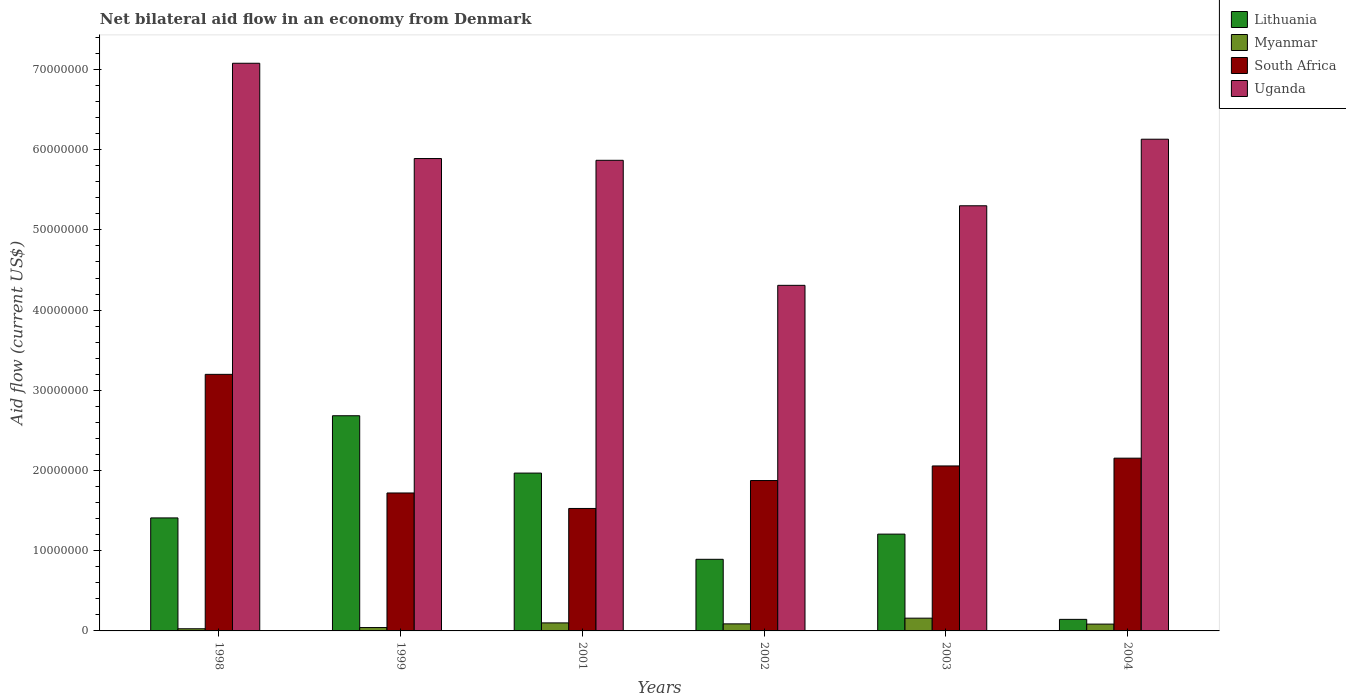How many different coloured bars are there?
Your response must be concise. 4. How many groups of bars are there?
Provide a succinct answer. 6. Are the number of bars per tick equal to the number of legend labels?
Offer a terse response. Yes. Are the number of bars on each tick of the X-axis equal?
Your answer should be very brief. Yes. How many bars are there on the 2nd tick from the left?
Offer a very short reply. 4. How many bars are there on the 1st tick from the right?
Offer a terse response. 4. What is the label of the 4th group of bars from the left?
Provide a succinct answer. 2002. In how many cases, is the number of bars for a given year not equal to the number of legend labels?
Make the answer very short. 0. What is the net bilateral aid flow in Myanmar in 1999?
Provide a succinct answer. 4.20e+05. Across all years, what is the maximum net bilateral aid flow in Myanmar?
Keep it short and to the point. 1.59e+06. Across all years, what is the minimum net bilateral aid flow in South Africa?
Your answer should be very brief. 1.53e+07. In which year was the net bilateral aid flow in Lithuania minimum?
Provide a short and direct response. 2004. What is the total net bilateral aid flow in Myanmar in the graph?
Your answer should be very brief. 5.01e+06. What is the difference between the net bilateral aid flow in Lithuania in 1998 and that in 2003?
Make the answer very short. 2.02e+06. What is the difference between the net bilateral aid flow in Lithuania in 1998 and the net bilateral aid flow in South Africa in 2001?
Provide a succinct answer. -1.18e+06. What is the average net bilateral aid flow in Lithuania per year?
Your response must be concise. 1.38e+07. In the year 2004, what is the difference between the net bilateral aid flow in South Africa and net bilateral aid flow in Lithuania?
Keep it short and to the point. 2.01e+07. What is the ratio of the net bilateral aid flow in South Africa in 2001 to that in 2003?
Make the answer very short. 0.74. Is the net bilateral aid flow in Lithuania in 2001 less than that in 2004?
Keep it short and to the point. No. What is the difference between the highest and the second highest net bilateral aid flow in South Africa?
Your response must be concise. 1.04e+07. What is the difference between the highest and the lowest net bilateral aid flow in Lithuania?
Keep it short and to the point. 2.54e+07. Is it the case that in every year, the sum of the net bilateral aid flow in South Africa and net bilateral aid flow in Uganda is greater than the sum of net bilateral aid flow in Myanmar and net bilateral aid flow in Lithuania?
Offer a terse response. Yes. What does the 1st bar from the left in 1998 represents?
Make the answer very short. Lithuania. What does the 1st bar from the right in 1999 represents?
Give a very brief answer. Uganda. Is it the case that in every year, the sum of the net bilateral aid flow in Uganda and net bilateral aid flow in Myanmar is greater than the net bilateral aid flow in South Africa?
Your response must be concise. Yes. Are all the bars in the graph horizontal?
Make the answer very short. No. How many years are there in the graph?
Keep it short and to the point. 6. What is the difference between two consecutive major ticks on the Y-axis?
Offer a very short reply. 1.00e+07. Are the values on the major ticks of Y-axis written in scientific E-notation?
Provide a succinct answer. No. Where does the legend appear in the graph?
Offer a terse response. Top right. How are the legend labels stacked?
Make the answer very short. Vertical. What is the title of the graph?
Your response must be concise. Net bilateral aid flow in an economy from Denmark. Does "Mongolia" appear as one of the legend labels in the graph?
Keep it short and to the point. No. What is the label or title of the X-axis?
Your answer should be compact. Years. What is the label or title of the Y-axis?
Provide a short and direct response. Aid flow (current US$). What is the Aid flow (current US$) in Lithuania in 1998?
Provide a succinct answer. 1.41e+07. What is the Aid flow (current US$) of Myanmar in 1998?
Offer a terse response. 2.70e+05. What is the Aid flow (current US$) of South Africa in 1998?
Give a very brief answer. 3.20e+07. What is the Aid flow (current US$) in Uganda in 1998?
Make the answer very short. 7.08e+07. What is the Aid flow (current US$) of Lithuania in 1999?
Ensure brevity in your answer.  2.68e+07. What is the Aid flow (current US$) in South Africa in 1999?
Make the answer very short. 1.72e+07. What is the Aid flow (current US$) of Uganda in 1999?
Ensure brevity in your answer.  5.89e+07. What is the Aid flow (current US$) in Lithuania in 2001?
Your answer should be compact. 1.97e+07. What is the Aid flow (current US$) of Myanmar in 2001?
Offer a terse response. 1.00e+06. What is the Aid flow (current US$) in South Africa in 2001?
Keep it short and to the point. 1.53e+07. What is the Aid flow (current US$) of Uganda in 2001?
Your answer should be very brief. 5.87e+07. What is the Aid flow (current US$) in Lithuania in 2002?
Offer a terse response. 8.93e+06. What is the Aid flow (current US$) in Myanmar in 2002?
Offer a terse response. 8.80e+05. What is the Aid flow (current US$) of South Africa in 2002?
Your answer should be compact. 1.88e+07. What is the Aid flow (current US$) of Uganda in 2002?
Keep it short and to the point. 4.31e+07. What is the Aid flow (current US$) of Lithuania in 2003?
Give a very brief answer. 1.21e+07. What is the Aid flow (current US$) of Myanmar in 2003?
Offer a terse response. 1.59e+06. What is the Aid flow (current US$) in South Africa in 2003?
Provide a short and direct response. 2.06e+07. What is the Aid flow (current US$) in Uganda in 2003?
Make the answer very short. 5.30e+07. What is the Aid flow (current US$) in Lithuania in 2004?
Offer a very short reply. 1.44e+06. What is the Aid flow (current US$) of Myanmar in 2004?
Your answer should be very brief. 8.50e+05. What is the Aid flow (current US$) in South Africa in 2004?
Keep it short and to the point. 2.15e+07. What is the Aid flow (current US$) in Uganda in 2004?
Provide a succinct answer. 6.13e+07. Across all years, what is the maximum Aid flow (current US$) of Lithuania?
Your response must be concise. 2.68e+07. Across all years, what is the maximum Aid flow (current US$) in Myanmar?
Offer a terse response. 1.59e+06. Across all years, what is the maximum Aid flow (current US$) in South Africa?
Keep it short and to the point. 3.20e+07. Across all years, what is the maximum Aid flow (current US$) in Uganda?
Provide a short and direct response. 7.08e+07. Across all years, what is the minimum Aid flow (current US$) of Lithuania?
Your answer should be compact. 1.44e+06. Across all years, what is the minimum Aid flow (current US$) of South Africa?
Your response must be concise. 1.53e+07. Across all years, what is the minimum Aid flow (current US$) in Uganda?
Offer a very short reply. 4.31e+07. What is the total Aid flow (current US$) of Lithuania in the graph?
Provide a succinct answer. 8.30e+07. What is the total Aid flow (current US$) of Myanmar in the graph?
Ensure brevity in your answer.  5.01e+06. What is the total Aid flow (current US$) in South Africa in the graph?
Your answer should be compact. 1.25e+08. What is the total Aid flow (current US$) in Uganda in the graph?
Offer a terse response. 3.46e+08. What is the difference between the Aid flow (current US$) of Lithuania in 1998 and that in 1999?
Make the answer very short. -1.27e+07. What is the difference between the Aid flow (current US$) of South Africa in 1998 and that in 1999?
Provide a succinct answer. 1.48e+07. What is the difference between the Aid flow (current US$) in Uganda in 1998 and that in 1999?
Offer a terse response. 1.19e+07. What is the difference between the Aid flow (current US$) in Lithuania in 1998 and that in 2001?
Offer a very short reply. -5.59e+06. What is the difference between the Aid flow (current US$) in Myanmar in 1998 and that in 2001?
Keep it short and to the point. -7.30e+05. What is the difference between the Aid flow (current US$) of South Africa in 1998 and that in 2001?
Offer a terse response. 1.67e+07. What is the difference between the Aid flow (current US$) in Uganda in 1998 and that in 2001?
Your response must be concise. 1.21e+07. What is the difference between the Aid flow (current US$) in Lithuania in 1998 and that in 2002?
Give a very brief answer. 5.16e+06. What is the difference between the Aid flow (current US$) of Myanmar in 1998 and that in 2002?
Make the answer very short. -6.10e+05. What is the difference between the Aid flow (current US$) in South Africa in 1998 and that in 2002?
Provide a succinct answer. 1.32e+07. What is the difference between the Aid flow (current US$) in Uganda in 1998 and that in 2002?
Provide a succinct answer. 2.77e+07. What is the difference between the Aid flow (current US$) of Lithuania in 1998 and that in 2003?
Provide a short and direct response. 2.02e+06. What is the difference between the Aid flow (current US$) of Myanmar in 1998 and that in 2003?
Your answer should be compact. -1.32e+06. What is the difference between the Aid flow (current US$) in South Africa in 1998 and that in 2003?
Provide a short and direct response. 1.14e+07. What is the difference between the Aid flow (current US$) in Uganda in 1998 and that in 2003?
Keep it short and to the point. 1.78e+07. What is the difference between the Aid flow (current US$) in Lithuania in 1998 and that in 2004?
Keep it short and to the point. 1.26e+07. What is the difference between the Aid flow (current US$) of Myanmar in 1998 and that in 2004?
Offer a terse response. -5.80e+05. What is the difference between the Aid flow (current US$) in South Africa in 1998 and that in 2004?
Offer a very short reply. 1.04e+07. What is the difference between the Aid flow (current US$) of Uganda in 1998 and that in 2004?
Make the answer very short. 9.47e+06. What is the difference between the Aid flow (current US$) of Lithuania in 1999 and that in 2001?
Provide a short and direct response. 7.15e+06. What is the difference between the Aid flow (current US$) of Myanmar in 1999 and that in 2001?
Provide a succinct answer. -5.80e+05. What is the difference between the Aid flow (current US$) in South Africa in 1999 and that in 2001?
Ensure brevity in your answer.  1.93e+06. What is the difference between the Aid flow (current US$) of Uganda in 1999 and that in 2001?
Make the answer very short. 2.20e+05. What is the difference between the Aid flow (current US$) in Lithuania in 1999 and that in 2002?
Ensure brevity in your answer.  1.79e+07. What is the difference between the Aid flow (current US$) of Myanmar in 1999 and that in 2002?
Offer a terse response. -4.60e+05. What is the difference between the Aid flow (current US$) in South Africa in 1999 and that in 2002?
Make the answer very short. -1.55e+06. What is the difference between the Aid flow (current US$) of Uganda in 1999 and that in 2002?
Give a very brief answer. 1.58e+07. What is the difference between the Aid flow (current US$) in Lithuania in 1999 and that in 2003?
Provide a succinct answer. 1.48e+07. What is the difference between the Aid flow (current US$) of Myanmar in 1999 and that in 2003?
Your answer should be compact. -1.17e+06. What is the difference between the Aid flow (current US$) in South Africa in 1999 and that in 2003?
Make the answer very short. -3.37e+06. What is the difference between the Aid flow (current US$) in Uganda in 1999 and that in 2003?
Offer a terse response. 5.89e+06. What is the difference between the Aid flow (current US$) in Lithuania in 1999 and that in 2004?
Provide a succinct answer. 2.54e+07. What is the difference between the Aid flow (current US$) of Myanmar in 1999 and that in 2004?
Your answer should be very brief. -4.30e+05. What is the difference between the Aid flow (current US$) of South Africa in 1999 and that in 2004?
Your response must be concise. -4.34e+06. What is the difference between the Aid flow (current US$) of Uganda in 1999 and that in 2004?
Provide a succinct answer. -2.41e+06. What is the difference between the Aid flow (current US$) of Lithuania in 2001 and that in 2002?
Keep it short and to the point. 1.08e+07. What is the difference between the Aid flow (current US$) of Myanmar in 2001 and that in 2002?
Your answer should be very brief. 1.20e+05. What is the difference between the Aid flow (current US$) in South Africa in 2001 and that in 2002?
Provide a short and direct response. -3.48e+06. What is the difference between the Aid flow (current US$) in Uganda in 2001 and that in 2002?
Provide a succinct answer. 1.56e+07. What is the difference between the Aid flow (current US$) of Lithuania in 2001 and that in 2003?
Offer a terse response. 7.61e+06. What is the difference between the Aid flow (current US$) in Myanmar in 2001 and that in 2003?
Offer a very short reply. -5.90e+05. What is the difference between the Aid flow (current US$) in South Africa in 2001 and that in 2003?
Provide a short and direct response. -5.30e+06. What is the difference between the Aid flow (current US$) of Uganda in 2001 and that in 2003?
Keep it short and to the point. 5.67e+06. What is the difference between the Aid flow (current US$) of Lithuania in 2001 and that in 2004?
Offer a very short reply. 1.82e+07. What is the difference between the Aid flow (current US$) of South Africa in 2001 and that in 2004?
Your answer should be compact. -6.27e+06. What is the difference between the Aid flow (current US$) in Uganda in 2001 and that in 2004?
Provide a succinct answer. -2.63e+06. What is the difference between the Aid flow (current US$) of Lithuania in 2002 and that in 2003?
Give a very brief answer. -3.14e+06. What is the difference between the Aid flow (current US$) in Myanmar in 2002 and that in 2003?
Provide a succinct answer. -7.10e+05. What is the difference between the Aid flow (current US$) of South Africa in 2002 and that in 2003?
Your response must be concise. -1.82e+06. What is the difference between the Aid flow (current US$) in Uganda in 2002 and that in 2003?
Offer a very short reply. -9.92e+06. What is the difference between the Aid flow (current US$) of Lithuania in 2002 and that in 2004?
Keep it short and to the point. 7.49e+06. What is the difference between the Aid flow (current US$) in Myanmar in 2002 and that in 2004?
Make the answer very short. 3.00e+04. What is the difference between the Aid flow (current US$) in South Africa in 2002 and that in 2004?
Your answer should be compact. -2.79e+06. What is the difference between the Aid flow (current US$) in Uganda in 2002 and that in 2004?
Your answer should be very brief. -1.82e+07. What is the difference between the Aid flow (current US$) of Lithuania in 2003 and that in 2004?
Give a very brief answer. 1.06e+07. What is the difference between the Aid flow (current US$) in Myanmar in 2003 and that in 2004?
Your answer should be compact. 7.40e+05. What is the difference between the Aid flow (current US$) of South Africa in 2003 and that in 2004?
Your response must be concise. -9.70e+05. What is the difference between the Aid flow (current US$) in Uganda in 2003 and that in 2004?
Provide a short and direct response. -8.30e+06. What is the difference between the Aid flow (current US$) in Lithuania in 1998 and the Aid flow (current US$) in Myanmar in 1999?
Keep it short and to the point. 1.37e+07. What is the difference between the Aid flow (current US$) in Lithuania in 1998 and the Aid flow (current US$) in South Africa in 1999?
Keep it short and to the point. -3.11e+06. What is the difference between the Aid flow (current US$) in Lithuania in 1998 and the Aid flow (current US$) in Uganda in 1999?
Offer a very short reply. -4.48e+07. What is the difference between the Aid flow (current US$) in Myanmar in 1998 and the Aid flow (current US$) in South Africa in 1999?
Offer a very short reply. -1.69e+07. What is the difference between the Aid flow (current US$) in Myanmar in 1998 and the Aid flow (current US$) in Uganda in 1999?
Offer a terse response. -5.86e+07. What is the difference between the Aid flow (current US$) in South Africa in 1998 and the Aid flow (current US$) in Uganda in 1999?
Your answer should be compact. -2.69e+07. What is the difference between the Aid flow (current US$) in Lithuania in 1998 and the Aid flow (current US$) in Myanmar in 2001?
Make the answer very short. 1.31e+07. What is the difference between the Aid flow (current US$) of Lithuania in 1998 and the Aid flow (current US$) of South Africa in 2001?
Give a very brief answer. -1.18e+06. What is the difference between the Aid flow (current US$) of Lithuania in 1998 and the Aid flow (current US$) of Uganda in 2001?
Make the answer very short. -4.46e+07. What is the difference between the Aid flow (current US$) of Myanmar in 1998 and the Aid flow (current US$) of South Africa in 2001?
Offer a very short reply. -1.50e+07. What is the difference between the Aid flow (current US$) in Myanmar in 1998 and the Aid flow (current US$) in Uganda in 2001?
Make the answer very short. -5.84e+07. What is the difference between the Aid flow (current US$) of South Africa in 1998 and the Aid flow (current US$) of Uganda in 2001?
Provide a short and direct response. -2.67e+07. What is the difference between the Aid flow (current US$) of Lithuania in 1998 and the Aid flow (current US$) of Myanmar in 2002?
Provide a succinct answer. 1.32e+07. What is the difference between the Aid flow (current US$) in Lithuania in 1998 and the Aid flow (current US$) in South Africa in 2002?
Your answer should be very brief. -4.66e+06. What is the difference between the Aid flow (current US$) of Lithuania in 1998 and the Aid flow (current US$) of Uganda in 2002?
Ensure brevity in your answer.  -2.90e+07. What is the difference between the Aid flow (current US$) of Myanmar in 1998 and the Aid flow (current US$) of South Africa in 2002?
Offer a terse response. -1.85e+07. What is the difference between the Aid flow (current US$) in Myanmar in 1998 and the Aid flow (current US$) in Uganda in 2002?
Make the answer very short. -4.28e+07. What is the difference between the Aid flow (current US$) in South Africa in 1998 and the Aid flow (current US$) in Uganda in 2002?
Make the answer very short. -1.11e+07. What is the difference between the Aid flow (current US$) of Lithuania in 1998 and the Aid flow (current US$) of Myanmar in 2003?
Give a very brief answer. 1.25e+07. What is the difference between the Aid flow (current US$) of Lithuania in 1998 and the Aid flow (current US$) of South Africa in 2003?
Give a very brief answer. -6.48e+06. What is the difference between the Aid flow (current US$) of Lithuania in 1998 and the Aid flow (current US$) of Uganda in 2003?
Provide a short and direct response. -3.89e+07. What is the difference between the Aid flow (current US$) in Myanmar in 1998 and the Aid flow (current US$) in South Africa in 2003?
Provide a succinct answer. -2.03e+07. What is the difference between the Aid flow (current US$) in Myanmar in 1998 and the Aid flow (current US$) in Uganda in 2003?
Offer a terse response. -5.27e+07. What is the difference between the Aid flow (current US$) in South Africa in 1998 and the Aid flow (current US$) in Uganda in 2003?
Your response must be concise. -2.10e+07. What is the difference between the Aid flow (current US$) of Lithuania in 1998 and the Aid flow (current US$) of Myanmar in 2004?
Keep it short and to the point. 1.32e+07. What is the difference between the Aid flow (current US$) in Lithuania in 1998 and the Aid flow (current US$) in South Africa in 2004?
Ensure brevity in your answer.  -7.45e+06. What is the difference between the Aid flow (current US$) in Lithuania in 1998 and the Aid flow (current US$) in Uganda in 2004?
Your answer should be very brief. -4.72e+07. What is the difference between the Aid flow (current US$) of Myanmar in 1998 and the Aid flow (current US$) of South Africa in 2004?
Offer a very short reply. -2.13e+07. What is the difference between the Aid flow (current US$) in Myanmar in 1998 and the Aid flow (current US$) in Uganda in 2004?
Make the answer very short. -6.10e+07. What is the difference between the Aid flow (current US$) in South Africa in 1998 and the Aid flow (current US$) in Uganda in 2004?
Give a very brief answer. -2.93e+07. What is the difference between the Aid flow (current US$) in Lithuania in 1999 and the Aid flow (current US$) in Myanmar in 2001?
Your response must be concise. 2.58e+07. What is the difference between the Aid flow (current US$) of Lithuania in 1999 and the Aid flow (current US$) of South Africa in 2001?
Give a very brief answer. 1.16e+07. What is the difference between the Aid flow (current US$) of Lithuania in 1999 and the Aid flow (current US$) of Uganda in 2001?
Offer a terse response. -3.18e+07. What is the difference between the Aid flow (current US$) in Myanmar in 1999 and the Aid flow (current US$) in South Africa in 2001?
Make the answer very short. -1.48e+07. What is the difference between the Aid flow (current US$) in Myanmar in 1999 and the Aid flow (current US$) in Uganda in 2001?
Your answer should be compact. -5.83e+07. What is the difference between the Aid flow (current US$) in South Africa in 1999 and the Aid flow (current US$) in Uganda in 2001?
Your response must be concise. -4.15e+07. What is the difference between the Aid flow (current US$) of Lithuania in 1999 and the Aid flow (current US$) of Myanmar in 2002?
Make the answer very short. 2.60e+07. What is the difference between the Aid flow (current US$) of Lithuania in 1999 and the Aid flow (current US$) of South Africa in 2002?
Keep it short and to the point. 8.08e+06. What is the difference between the Aid flow (current US$) in Lithuania in 1999 and the Aid flow (current US$) in Uganda in 2002?
Your answer should be compact. -1.63e+07. What is the difference between the Aid flow (current US$) in Myanmar in 1999 and the Aid flow (current US$) in South Africa in 2002?
Provide a short and direct response. -1.83e+07. What is the difference between the Aid flow (current US$) of Myanmar in 1999 and the Aid flow (current US$) of Uganda in 2002?
Keep it short and to the point. -4.27e+07. What is the difference between the Aid flow (current US$) in South Africa in 1999 and the Aid flow (current US$) in Uganda in 2002?
Offer a terse response. -2.59e+07. What is the difference between the Aid flow (current US$) in Lithuania in 1999 and the Aid flow (current US$) in Myanmar in 2003?
Offer a very short reply. 2.52e+07. What is the difference between the Aid flow (current US$) in Lithuania in 1999 and the Aid flow (current US$) in South Africa in 2003?
Offer a terse response. 6.26e+06. What is the difference between the Aid flow (current US$) in Lithuania in 1999 and the Aid flow (current US$) in Uganda in 2003?
Provide a short and direct response. -2.62e+07. What is the difference between the Aid flow (current US$) of Myanmar in 1999 and the Aid flow (current US$) of South Africa in 2003?
Offer a terse response. -2.02e+07. What is the difference between the Aid flow (current US$) in Myanmar in 1999 and the Aid flow (current US$) in Uganda in 2003?
Your response must be concise. -5.26e+07. What is the difference between the Aid flow (current US$) in South Africa in 1999 and the Aid flow (current US$) in Uganda in 2003?
Your answer should be compact. -3.58e+07. What is the difference between the Aid flow (current US$) in Lithuania in 1999 and the Aid flow (current US$) in Myanmar in 2004?
Your answer should be compact. 2.60e+07. What is the difference between the Aid flow (current US$) in Lithuania in 1999 and the Aid flow (current US$) in South Africa in 2004?
Your answer should be compact. 5.29e+06. What is the difference between the Aid flow (current US$) in Lithuania in 1999 and the Aid flow (current US$) in Uganda in 2004?
Provide a short and direct response. -3.45e+07. What is the difference between the Aid flow (current US$) of Myanmar in 1999 and the Aid flow (current US$) of South Africa in 2004?
Provide a succinct answer. -2.11e+07. What is the difference between the Aid flow (current US$) of Myanmar in 1999 and the Aid flow (current US$) of Uganda in 2004?
Offer a terse response. -6.09e+07. What is the difference between the Aid flow (current US$) of South Africa in 1999 and the Aid flow (current US$) of Uganda in 2004?
Provide a short and direct response. -4.41e+07. What is the difference between the Aid flow (current US$) in Lithuania in 2001 and the Aid flow (current US$) in Myanmar in 2002?
Your response must be concise. 1.88e+07. What is the difference between the Aid flow (current US$) of Lithuania in 2001 and the Aid flow (current US$) of South Africa in 2002?
Provide a succinct answer. 9.30e+05. What is the difference between the Aid flow (current US$) in Lithuania in 2001 and the Aid flow (current US$) in Uganda in 2002?
Provide a succinct answer. -2.34e+07. What is the difference between the Aid flow (current US$) of Myanmar in 2001 and the Aid flow (current US$) of South Africa in 2002?
Your response must be concise. -1.78e+07. What is the difference between the Aid flow (current US$) in Myanmar in 2001 and the Aid flow (current US$) in Uganda in 2002?
Offer a very short reply. -4.21e+07. What is the difference between the Aid flow (current US$) of South Africa in 2001 and the Aid flow (current US$) of Uganda in 2002?
Provide a short and direct response. -2.78e+07. What is the difference between the Aid flow (current US$) in Lithuania in 2001 and the Aid flow (current US$) in Myanmar in 2003?
Your answer should be compact. 1.81e+07. What is the difference between the Aid flow (current US$) of Lithuania in 2001 and the Aid flow (current US$) of South Africa in 2003?
Ensure brevity in your answer.  -8.90e+05. What is the difference between the Aid flow (current US$) in Lithuania in 2001 and the Aid flow (current US$) in Uganda in 2003?
Your answer should be compact. -3.33e+07. What is the difference between the Aid flow (current US$) of Myanmar in 2001 and the Aid flow (current US$) of South Africa in 2003?
Your answer should be very brief. -1.96e+07. What is the difference between the Aid flow (current US$) of Myanmar in 2001 and the Aid flow (current US$) of Uganda in 2003?
Make the answer very short. -5.20e+07. What is the difference between the Aid flow (current US$) of South Africa in 2001 and the Aid flow (current US$) of Uganda in 2003?
Provide a short and direct response. -3.77e+07. What is the difference between the Aid flow (current US$) in Lithuania in 2001 and the Aid flow (current US$) in Myanmar in 2004?
Your answer should be compact. 1.88e+07. What is the difference between the Aid flow (current US$) in Lithuania in 2001 and the Aid flow (current US$) in South Africa in 2004?
Your answer should be very brief. -1.86e+06. What is the difference between the Aid flow (current US$) in Lithuania in 2001 and the Aid flow (current US$) in Uganda in 2004?
Offer a terse response. -4.16e+07. What is the difference between the Aid flow (current US$) of Myanmar in 2001 and the Aid flow (current US$) of South Africa in 2004?
Give a very brief answer. -2.05e+07. What is the difference between the Aid flow (current US$) of Myanmar in 2001 and the Aid flow (current US$) of Uganda in 2004?
Provide a short and direct response. -6.03e+07. What is the difference between the Aid flow (current US$) of South Africa in 2001 and the Aid flow (current US$) of Uganda in 2004?
Your response must be concise. -4.60e+07. What is the difference between the Aid flow (current US$) in Lithuania in 2002 and the Aid flow (current US$) in Myanmar in 2003?
Your response must be concise. 7.34e+06. What is the difference between the Aid flow (current US$) of Lithuania in 2002 and the Aid flow (current US$) of South Africa in 2003?
Offer a very short reply. -1.16e+07. What is the difference between the Aid flow (current US$) in Lithuania in 2002 and the Aid flow (current US$) in Uganda in 2003?
Give a very brief answer. -4.41e+07. What is the difference between the Aid flow (current US$) of Myanmar in 2002 and the Aid flow (current US$) of South Africa in 2003?
Offer a terse response. -1.97e+07. What is the difference between the Aid flow (current US$) in Myanmar in 2002 and the Aid flow (current US$) in Uganda in 2003?
Provide a succinct answer. -5.21e+07. What is the difference between the Aid flow (current US$) of South Africa in 2002 and the Aid flow (current US$) of Uganda in 2003?
Keep it short and to the point. -3.43e+07. What is the difference between the Aid flow (current US$) of Lithuania in 2002 and the Aid flow (current US$) of Myanmar in 2004?
Provide a succinct answer. 8.08e+06. What is the difference between the Aid flow (current US$) in Lithuania in 2002 and the Aid flow (current US$) in South Africa in 2004?
Make the answer very short. -1.26e+07. What is the difference between the Aid flow (current US$) of Lithuania in 2002 and the Aid flow (current US$) of Uganda in 2004?
Provide a succinct answer. -5.24e+07. What is the difference between the Aid flow (current US$) in Myanmar in 2002 and the Aid flow (current US$) in South Africa in 2004?
Ensure brevity in your answer.  -2.07e+07. What is the difference between the Aid flow (current US$) of Myanmar in 2002 and the Aid flow (current US$) of Uganda in 2004?
Your answer should be very brief. -6.04e+07. What is the difference between the Aid flow (current US$) of South Africa in 2002 and the Aid flow (current US$) of Uganda in 2004?
Your answer should be compact. -4.26e+07. What is the difference between the Aid flow (current US$) in Lithuania in 2003 and the Aid flow (current US$) in Myanmar in 2004?
Keep it short and to the point. 1.12e+07. What is the difference between the Aid flow (current US$) in Lithuania in 2003 and the Aid flow (current US$) in South Africa in 2004?
Ensure brevity in your answer.  -9.47e+06. What is the difference between the Aid flow (current US$) in Lithuania in 2003 and the Aid flow (current US$) in Uganda in 2004?
Provide a succinct answer. -4.92e+07. What is the difference between the Aid flow (current US$) in Myanmar in 2003 and the Aid flow (current US$) in South Africa in 2004?
Your response must be concise. -2.00e+07. What is the difference between the Aid flow (current US$) in Myanmar in 2003 and the Aid flow (current US$) in Uganda in 2004?
Ensure brevity in your answer.  -5.97e+07. What is the difference between the Aid flow (current US$) of South Africa in 2003 and the Aid flow (current US$) of Uganda in 2004?
Provide a short and direct response. -4.07e+07. What is the average Aid flow (current US$) of Lithuania per year?
Your answer should be compact. 1.38e+07. What is the average Aid flow (current US$) of Myanmar per year?
Your response must be concise. 8.35e+05. What is the average Aid flow (current US$) of South Africa per year?
Offer a very short reply. 2.09e+07. What is the average Aid flow (current US$) of Uganda per year?
Ensure brevity in your answer.  5.76e+07. In the year 1998, what is the difference between the Aid flow (current US$) of Lithuania and Aid flow (current US$) of Myanmar?
Provide a succinct answer. 1.38e+07. In the year 1998, what is the difference between the Aid flow (current US$) in Lithuania and Aid flow (current US$) in South Africa?
Your answer should be compact. -1.79e+07. In the year 1998, what is the difference between the Aid flow (current US$) in Lithuania and Aid flow (current US$) in Uganda?
Your answer should be very brief. -5.67e+07. In the year 1998, what is the difference between the Aid flow (current US$) in Myanmar and Aid flow (current US$) in South Africa?
Keep it short and to the point. -3.17e+07. In the year 1998, what is the difference between the Aid flow (current US$) in Myanmar and Aid flow (current US$) in Uganda?
Offer a terse response. -7.05e+07. In the year 1998, what is the difference between the Aid flow (current US$) in South Africa and Aid flow (current US$) in Uganda?
Keep it short and to the point. -3.88e+07. In the year 1999, what is the difference between the Aid flow (current US$) of Lithuania and Aid flow (current US$) of Myanmar?
Your response must be concise. 2.64e+07. In the year 1999, what is the difference between the Aid flow (current US$) in Lithuania and Aid flow (current US$) in South Africa?
Ensure brevity in your answer.  9.63e+06. In the year 1999, what is the difference between the Aid flow (current US$) of Lithuania and Aid flow (current US$) of Uganda?
Your answer should be very brief. -3.21e+07. In the year 1999, what is the difference between the Aid flow (current US$) in Myanmar and Aid flow (current US$) in South Africa?
Ensure brevity in your answer.  -1.68e+07. In the year 1999, what is the difference between the Aid flow (current US$) in Myanmar and Aid flow (current US$) in Uganda?
Provide a short and direct response. -5.85e+07. In the year 1999, what is the difference between the Aid flow (current US$) of South Africa and Aid flow (current US$) of Uganda?
Provide a succinct answer. -4.17e+07. In the year 2001, what is the difference between the Aid flow (current US$) of Lithuania and Aid flow (current US$) of Myanmar?
Make the answer very short. 1.87e+07. In the year 2001, what is the difference between the Aid flow (current US$) of Lithuania and Aid flow (current US$) of South Africa?
Provide a succinct answer. 4.41e+06. In the year 2001, what is the difference between the Aid flow (current US$) in Lithuania and Aid flow (current US$) in Uganda?
Your response must be concise. -3.90e+07. In the year 2001, what is the difference between the Aid flow (current US$) in Myanmar and Aid flow (current US$) in South Africa?
Provide a short and direct response. -1.43e+07. In the year 2001, what is the difference between the Aid flow (current US$) in Myanmar and Aid flow (current US$) in Uganda?
Offer a very short reply. -5.77e+07. In the year 2001, what is the difference between the Aid flow (current US$) of South Africa and Aid flow (current US$) of Uganda?
Ensure brevity in your answer.  -4.34e+07. In the year 2002, what is the difference between the Aid flow (current US$) of Lithuania and Aid flow (current US$) of Myanmar?
Provide a succinct answer. 8.05e+06. In the year 2002, what is the difference between the Aid flow (current US$) of Lithuania and Aid flow (current US$) of South Africa?
Offer a very short reply. -9.82e+06. In the year 2002, what is the difference between the Aid flow (current US$) in Lithuania and Aid flow (current US$) in Uganda?
Offer a terse response. -3.42e+07. In the year 2002, what is the difference between the Aid flow (current US$) in Myanmar and Aid flow (current US$) in South Africa?
Keep it short and to the point. -1.79e+07. In the year 2002, what is the difference between the Aid flow (current US$) in Myanmar and Aid flow (current US$) in Uganda?
Provide a short and direct response. -4.22e+07. In the year 2002, what is the difference between the Aid flow (current US$) of South Africa and Aid flow (current US$) of Uganda?
Give a very brief answer. -2.43e+07. In the year 2003, what is the difference between the Aid flow (current US$) of Lithuania and Aid flow (current US$) of Myanmar?
Give a very brief answer. 1.05e+07. In the year 2003, what is the difference between the Aid flow (current US$) of Lithuania and Aid flow (current US$) of South Africa?
Make the answer very short. -8.50e+06. In the year 2003, what is the difference between the Aid flow (current US$) of Lithuania and Aid flow (current US$) of Uganda?
Give a very brief answer. -4.09e+07. In the year 2003, what is the difference between the Aid flow (current US$) in Myanmar and Aid flow (current US$) in South Africa?
Keep it short and to the point. -1.90e+07. In the year 2003, what is the difference between the Aid flow (current US$) in Myanmar and Aid flow (current US$) in Uganda?
Your answer should be compact. -5.14e+07. In the year 2003, what is the difference between the Aid flow (current US$) in South Africa and Aid flow (current US$) in Uganda?
Your answer should be very brief. -3.24e+07. In the year 2004, what is the difference between the Aid flow (current US$) in Lithuania and Aid flow (current US$) in Myanmar?
Your answer should be very brief. 5.90e+05. In the year 2004, what is the difference between the Aid flow (current US$) in Lithuania and Aid flow (current US$) in South Africa?
Provide a short and direct response. -2.01e+07. In the year 2004, what is the difference between the Aid flow (current US$) in Lithuania and Aid flow (current US$) in Uganda?
Your response must be concise. -5.99e+07. In the year 2004, what is the difference between the Aid flow (current US$) in Myanmar and Aid flow (current US$) in South Africa?
Provide a succinct answer. -2.07e+07. In the year 2004, what is the difference between the Aid flow (current US$) of Myanmar and Aid flow (current US$) of Uganda?
Keep it short and to the point. -6.05e+07. In the year 2004, what is the difference between the Aid flow (current US$) in South Africa and Aid flow (current US$) in Uganda?
Offer a very short reply. -3.98e+07. What is the ratio of the Aid flow (current US$) in Lithuania in 1998 to that in 1999?
Keep it short and to the point. 0.53. What is the ratio of the Aid flow (current US$) in Myanmar in 1998 to that in 1999?
Make the answer very short. 0.64. What is the ratio of the Aid flow (current US$) of South Africa in 1998 to that in 1999?
Offer a terse response. 1.86. What is the ratio of the Aid flow (current US$) of Uganda in 1998 to that in 1999?
Your answer should be very brief. 1.2. What is the ratio of the Aid flow (current US$) in Lithuania in 1998 to that in 2001?
Your response must be concise. 0.72. What is the ratio of the Aid flow (current US$) of Myanmar in 1998 to that in 2001?
Your answer should be compact. 0.27. What is the ratio of the Aid flow (current US$) of South Africa in 1998 to that in 2001?
Make the answer very short. 2.1. What is the ratio of the Aid flow (current US$) of Uganda in 1998 to that in 2001?
Offer a terse response. 1.21. What is the ratio of the Aid flow (current US$) in Lithuania in 1998 to that in 2002?
Ensure brevity in your answer.  1.58. What is the ratio of the Aid flow (current US$) in Myanmar in 1998 to that in 2002?
Give a very brief answer. 0.31. What is the ratio of the Aid flow (current US$) of South Africa in 1998 to that in 2002?
Ensure brevity in your answer.  1.71. What is the ratio of the Aid flow (current US$) in Uganda in 1998 to that in 2002?
Provide a succinct answer. 1.64. What is the ratio of the Aid flow (current US$) in Lithuania in 1998 to that in 2003?
Keep it short and to the point. 1.17. What is the ratio of the Aid flow (current US$) in Myanmar in 1998 to that in 2003?
Offer a terse response. 0.17. What is the ratio of the Aid flow (current US$) of South Africa in 1998 to that in 2003?
Keep it short and to the point. 1.56. What is the ratio of the Aid flow (current US$) of Uganda in 1998 to that in 2003?
Provide a succinct answer. 1.34. What is the ratio of the Aid flow (current US$) in Lithuania in 1998 to that in 2004?
Offer a terse response. 9.78. What is the ratio of the Aid flow (current US$) in Myanmar in 1998 to that in 2004?
Offer a very short reply. 0.32. What is the ratio of the Aid flow (current US$) in South Africa in 1998 to that in 2004?
Give a very brief answer. 1.49. What is the ratio of the Aid flow (current US$) in Uganda in 1998 to that in 2004?
Provide a succinct answer. 1.15. What is the ratio of the Aid flow (current US$) in Lithuania in 1999 to that in 2001?
Provide a succinct answer. 1.36. What is the ratio of the Aid flow (current US$) in Myanmar in 1999 to that in 2001?
Your answer should be very brief. 0.42. What is the ratio of the Aid flow (current US$) of South Africa in 1999 to that in 2001?
Keep it short and to the point. 1.13. What is the ratio of the Aid flow (current US$) of Lithuania in 1999 to that in 2002?
Your answer should be very brief. 3. What is the ratio of the Aid flow (current US$) in Myanmar in 1999 to that in 2002?
Give a very brief answer. 0.48. What is the ratio of the Aid flow (current US$) of South Africa in 1999 to that in 2002?
Make the answer very short. 0.92. What is the ratio of the Aid flow (current US$) in Uganda in 1999 to that in 2002?
Your response must be concise. 1.37. What is the ratio of the Aid flow (current US$) in Lithuania in 1999 to that in 2003?
Keep it short and to the point. 2.22. What is the ratio of the Aid flow (current US$) of Myanmar in 1999 to that in 2003?
Your answer should be very brief. 0.26. What is the ratio of the Aid flow (current US$) of South Africa in 1999 to that in 2003?
Provide a short and direct response. 0.84. What is the ratio of the Aid flow (current US$) in Uganda in 1999 to that in 2003?
Your response must be concise. 1.11. What is the ratio of the Aid flow (current US$) in Lithuania in 1999 to that in 2004?
Provide a succinct answer. 18.63. What is the ratio of the Aid flow (current US$) in Myanmar in 1999 to that in 2004?
Offer a very short reply. 0.49. What is the ratio of the Aid flow (current US$) in South Africa in 1999 to that in 2004?
Give a very brief answer. 0.8. What is the ratio of the Aid flow (current US$) of Uganda in 1999 to that in 2004?
Your answer should be compact. 0.96. What is the ratio of the Aid flow (current US$) of Lithuania in 2001 to that in 2002?
Keep it short and to the point. 2.2. What is the ratio of the Aid flow (current US$) in Myanmar in 2001 to that in 2002?
Your response must be concise. 1.14. What is the ratio of the Aid flow (current US$) in South Africa in 2001 to that in 2002?
Offer a very short reply. 0.81. What is the ratio of the Aid flow (current US$) in Uganda in 2001 to that in 2002?
Keep it short and to the point. 1.36. What is the ratio of the Aid flow (current US$) in Lithuania in 2001 to that in 2003?
Keep it short and to the point. 1.63. What is the ratio of the Aid flow (current US$) in Myanmar in 2001 to that in 2003?
Ensure brevity in your answer.  0.63. What is the ratio of the Aid flow (current US$) in South Africa in 2001 to that in 2003?
Make the answer very short. 0.74. What is the ratio of the Aid flow (current US$) of Uganda in 2001 to that in 2003?
Make the answer very short. 1.11. What is the ratio of the Aid flow (current US$) of Lithuania in 2001 to that in 2004?
Your answer should be compact. 13.67. What is the ratio of the Aid flow (current US$) of Myanmar in 2001 to that in 2004?
Make the answer very short. 1.18. What is the ratio of the Aid flow (current US$) in South Africa in 2001 to that in 2004?
Provide a succinct answer. 0.71. What is the ratio of the Aid flow (current US$) in Uganda in 2001 to that in 2004?
Give a very brief answer. 0.96. What is the ratio of the Aid flow (current US$) of Lithuania in 2002 to that in 2003?
Provide a succinct answer. 0.74. What is the ratio of the Aid flow (current US$) in Myanmar in 2002 to that in 2003?
Provide a succinct answer. 0.55. What is the ratio of the Aid flow (current US$) in South Africa in 2002 to that in 2003?
Make the answer very short. 0.91. What is the ratio of the Aid flow (current US$) in Uganda in 2002 to that in 2003?
Provide a succinct answer. 0.81. What is the ratio of the Aid flow (current US$) of Lithuania in 2002 to that in 2004?
Give a very brief answer. 6.2. What is the ratio of the Aid flow (current US$) of Myanmar in 2002 to that in 2004?
Offer a very short reply. 1.04. What is the ratio of the Aid flow (current US$) in South Africa in 2002 to that in 2004?
Give a very brief answer. 0.87. What is the ratio of the Aid flow (current US$) in Uganda in 2002 to that in 2004?
Offer a terse response. 0.7. What is the ratio of the Aid flow (current US$) in Lithuania in 2003 to that in 2004?
Your answer should be very brief. 8.38. What is the ratio of the Aid flow (current US$) in Myanmar in 2003 to that in 2004?
Provide a short and direct response. 1.87. What is the ratio of the Aid flow (current US$) of South Africa in 2003 to that in 2004?
Offer a very short reply. 0.95. What is the ratio of the Aid flow (current US$) in Uganda in 2003 to that in 2004?
Provide a succinct answer. 0.86. What is the difference between the highest and the second highest Aid flow (current US$) in Lithuania?
Offer a terse response. 7.15e+06. What is the difference between the highest and the second highest Aid flow (current US$) of Myanmar?
Offer a very short reply. 5.90e+05. What is the difference between the highest and the second highest Aid flow (current US$) in South Africa?
Provide a short and direct response. 1.04e+07. What is the difference between the highest and the second highest Aid flow (current US$) in Uganda?
Give a very brief answer. 9.47e+06. What is the difference between the highest and the lowest Aid flow (current US$) in Lithuania?
Offer a very short reply. 2.54e+07. What is the difference between the highest and the lowest Aid flow (current US$) in Myanmar?
Your answer should be compact. 1.32e+06. What is the difference between the highest and the lowest Aid flow (current US$) of South Africa?
Ensure brevity in your answer.  1.67e+07. What is the difference between the highest and the lowest Aid flow (current US$) of Uganda?
Your answer should be compact. 2.77e+07. 